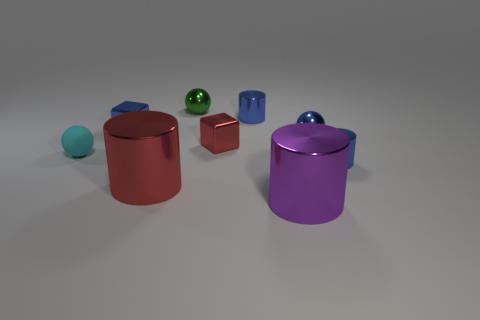Subtract all big purple shiny cylinders. How many cylinders are left? 3 Subtract all green spheres. How many blue cylinders are left? 2 Subtract 1 balls. How many balls are left? 2 Subtract all purple cylinders. How many cylinders are left? 3 Subtract all cubes. How many objects are left? 7 Subtract all gray cylinders. Subtract all blue balls. How many cylinders are left? 4 Subtract all tiny blue metallic blocks. Subtract all tiny red metal objects. How many objects are left? 7 Add 7 blue shiny spheres. How many blue shiny spheres are left? 8 Add 1 large gray matte objects. How many large gray matte objects exist? 1 Subtract 1 purple cylinders. How many objects are left? 8 